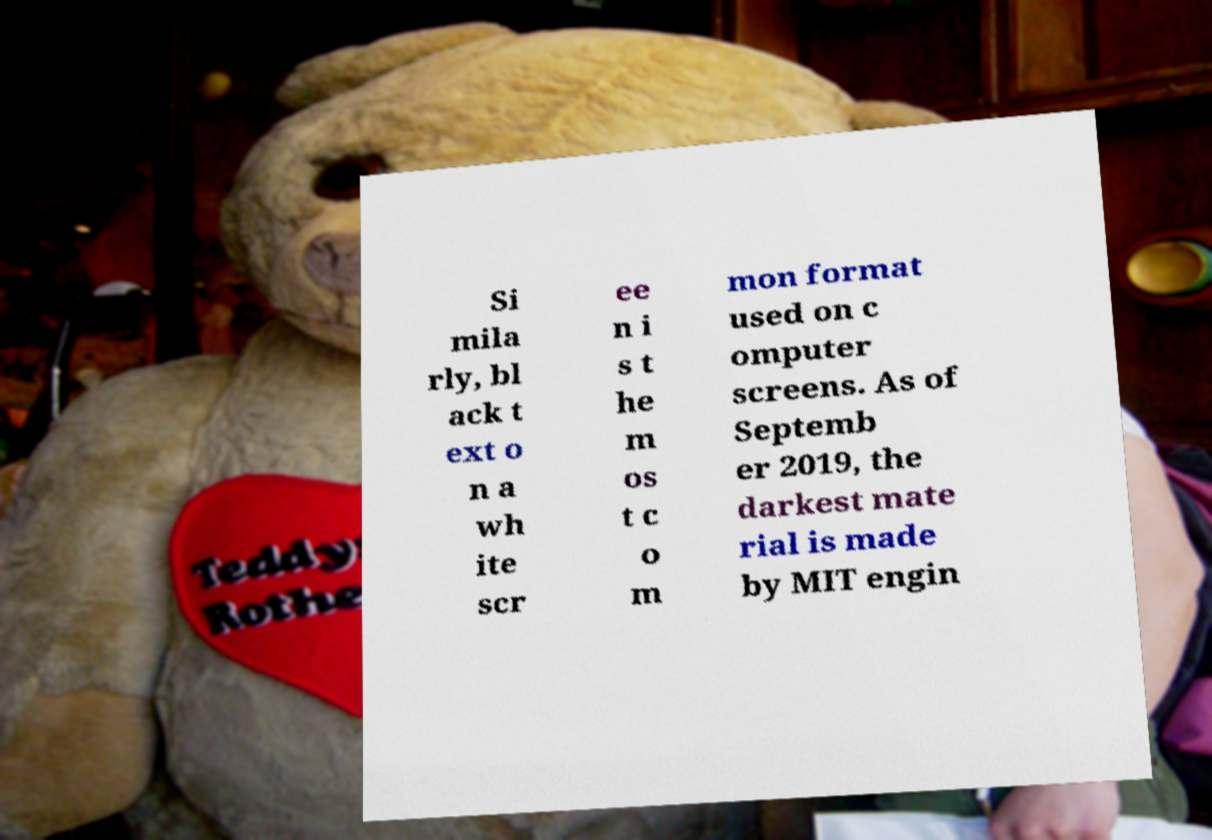There's text embedded in this image that I need extracted. Can you transcribe it verbatim? Si mila rly, bl ack t ext o n a wh ite scr ee n i s t he m os t c o m mon format used on c omputer screens. As of Septemb er 2019, the darkest mate rial is made by MIT engin 